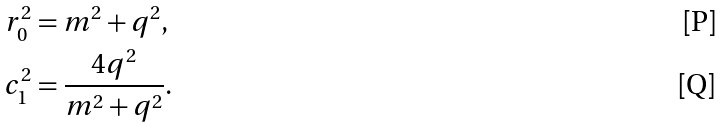<formula> <loc_0><loc_0><loc_500><loc_500>r _ { 0 } ^ { 2 } & = m ^ { 2 } + q ^ { 2 } , \\ c _ { 1 } ^ { 2 } & = \frac { 4 q ^ { 2 } } { m ^ { 2 } + q ^ { 2 } } .</formula> 